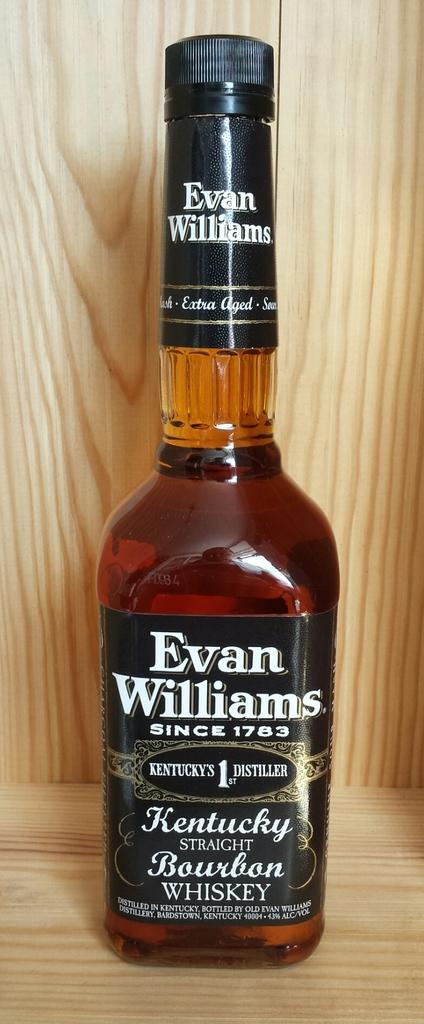What is the main object in the image? There is a whisky bottle in the image. What can be seen in the background of the image? The background of the image is wooden. What is the effect of the minute on the whisky bottle in the image? There is no mention of a minute or any time-related element in the image, so it is not possible to determine any effect on the whisky bottle. 